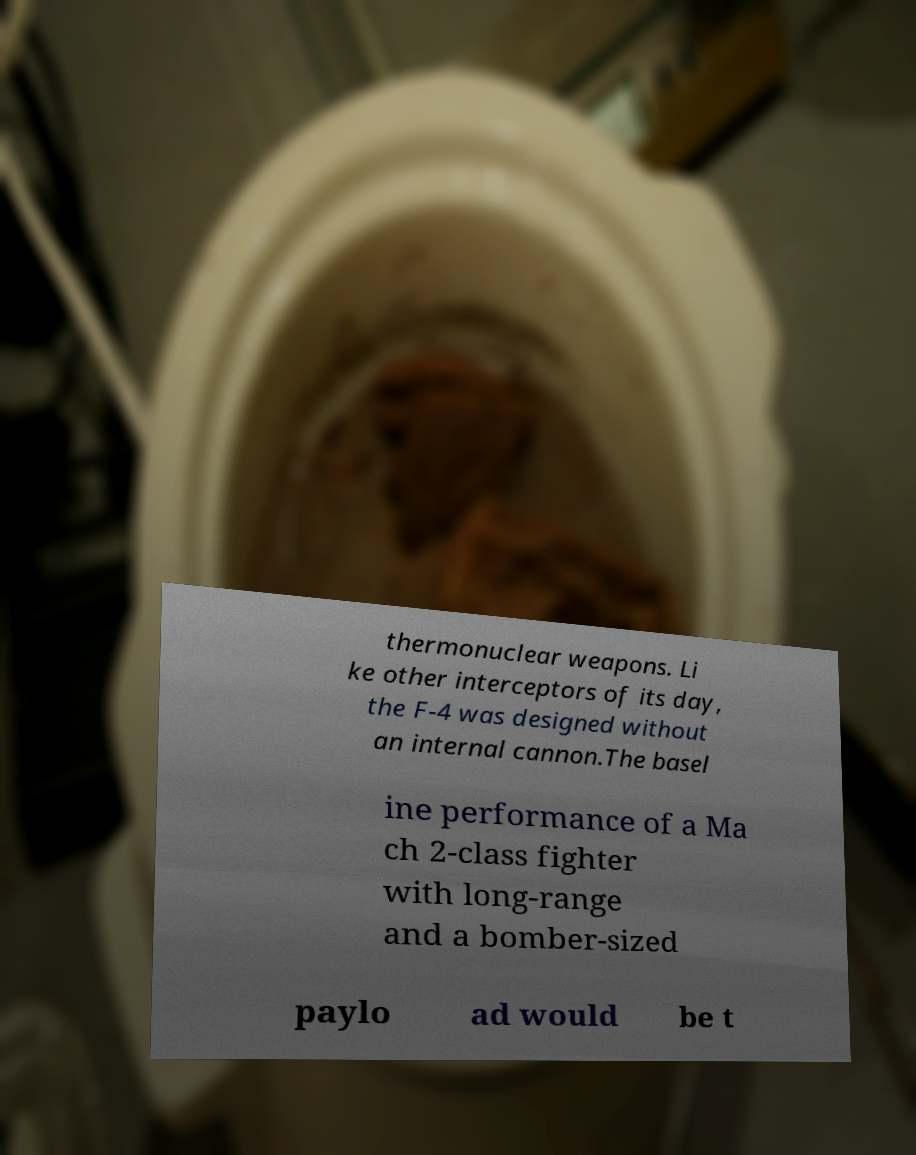Can you read and provide the text displayed in the image?This photo seems to have some interesting text. Can you extract and type it out for me? thermonuclear weapons. Li ke other interceptors of its day, the F-4 was designed without an internal cannon.The basel ine performance of a Ma ch 2-class fighter with long-range and a bomber-sized paylo ad would be t 